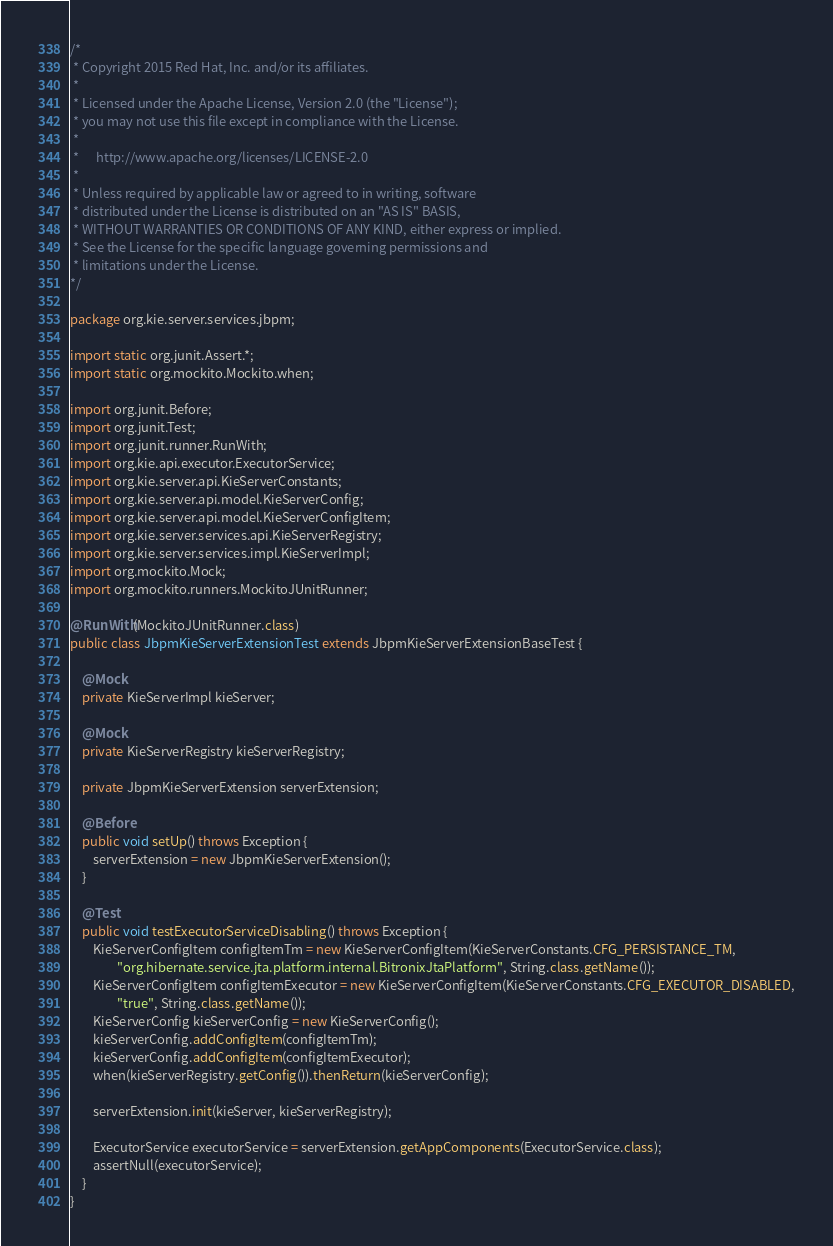Convert code to text. <code><loc_0><loc_0><loc_500><loc_500><_Java_>/*
 * Copyright 2015 Red Hat, Inc. and/or its affiliates.
 *
 * Licensed under the Apache License, Version 2.0 (the "License");
 * you may not use this file except in compliance with the License.
 *
 *      http://www.apache.org/licenses/LICENSE-2.0
 *
 * Unless required by applicable law or agreed to in writing, software
 * distributed under the License is distributed on an "AS IS" BASIS,
 * WITHOUT WARRANTIES OR CONDITIONS OF ANY KIND, either express or implied.
 * See the License for the specific language governing permissions and
 * limitations under the License.
*/

package org.kie.server.services.jbpm;

import static org.junit.Assert.*;
import static org.mockito.Mockito.when;

import org.junit.Before;
import org.junit.Test;
import org.junit.runner.RunWith;
import org.kie.api.executor.ExecutorService;
import org.kie.server.api.KieServerConstants;
import org.kie.server.api.model.KieServerConfig;
import org.kie.server.api.model.KieServerConfigItem;
import org.kie.server.services.api.KieServerRegistry;
import org.kie.server.services.impl.KieServerImpl;
import org.mockito.Mock;
import org.mockito.runners.MockitoJUnitRunner;

@RunWith(MockitoJUnitRunner.class)
public class JbpmKieServerExtensionTest extends JbpmKieServerExtensionBaseTest {

    @Mock
    private KieServerImpl kieServer;

    @Mock
    private KieServerRegistry kieServerRegistry;

    private JbpmKieServerExtension serverExtension;

    @Before
    public void setUp() throws Exception {
        serverExtension = new JbpmKieServerExtension();
    }

    @Test
    public void testExecutorServiceDisabling() throws Exception {
        KieServerConfigItem configItemTm = new KieServerConfigItem(KieServerConstants.CFG_PERSISTANCE_TM,
                "org.hibernate.service.jta.platform.internal.BitronixJtaPlatform", String.class.getName());
        KieServerConfigItem configItemExecutor = new KieServerConfigItem(KieServerConstants.CFG_EXECUTOR_DISABLED,
                "true", String.class.getName());
        KieServerConfig kieServerConfig = new KieServerConfig();
        kieServerConfig.addConfigItem(configItemTm);
        kieServerConfig.addConfigItem(configItemExecutor);
        when(kieServerRegistry.getConfig()).thenReturn(kieServerConfig);

        serverExtension.init(kieServer, kieServerRegistry);

        ExecutorService executorService = serverExtension.getAppComponents(ExecutorService.class);
        assertNull(executorService);
    }
}
</code> 